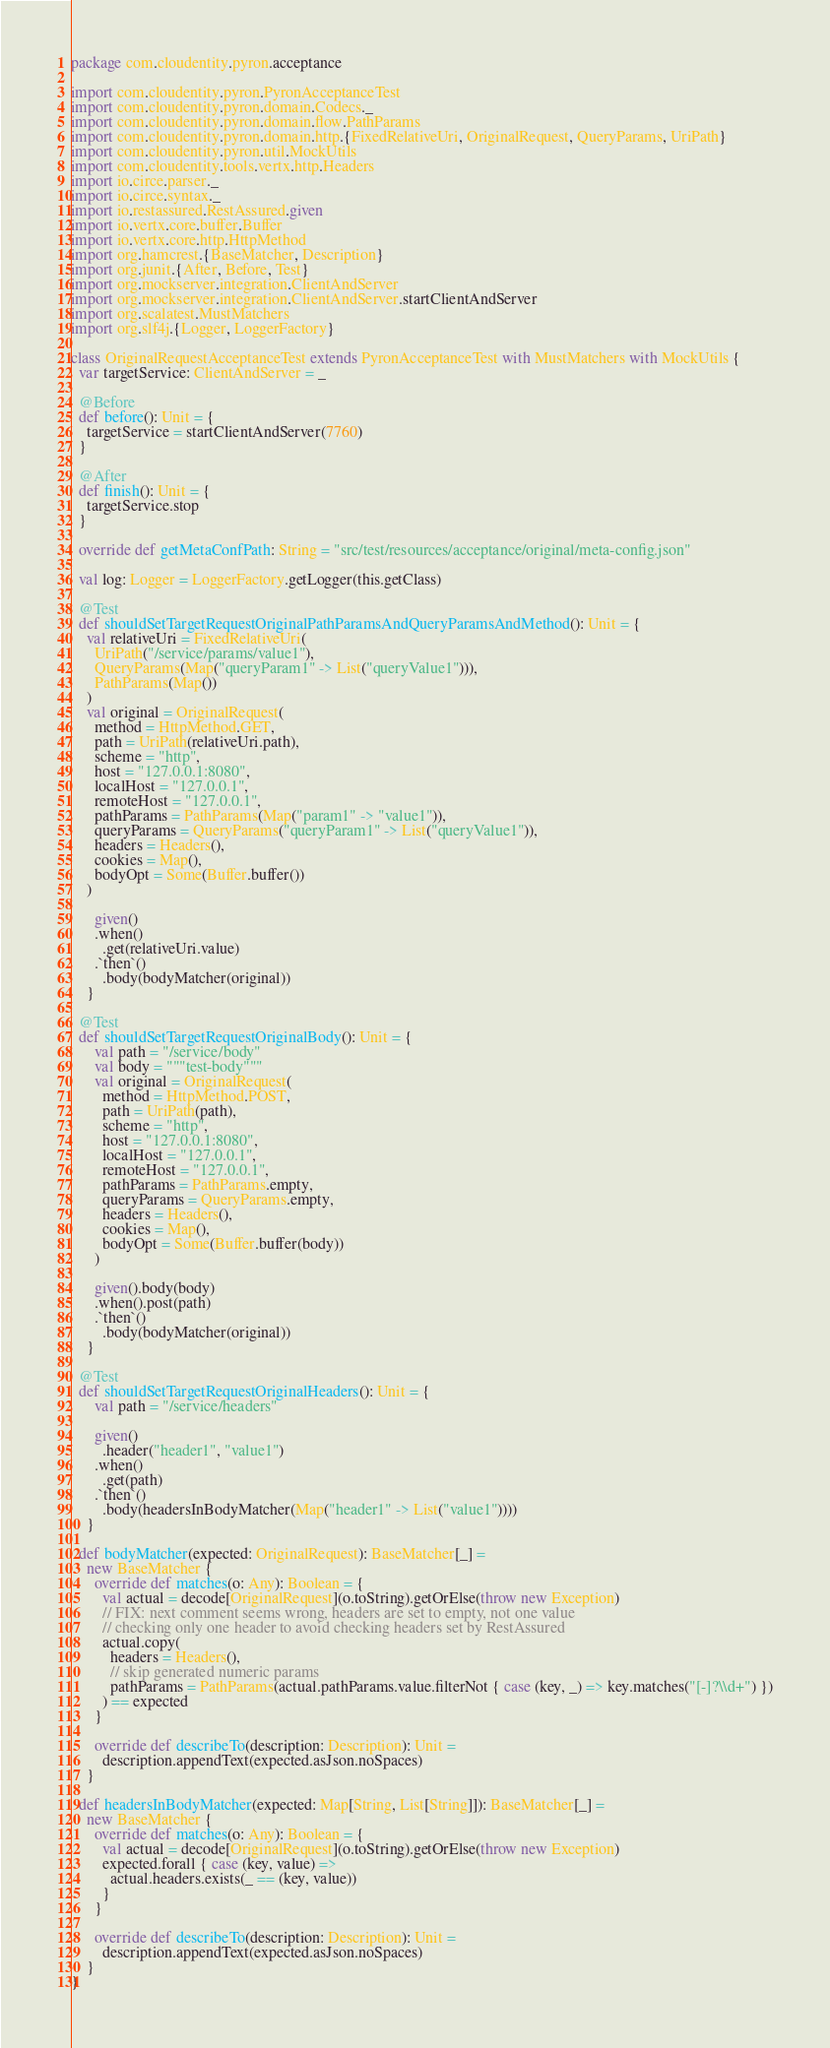<code> <loc_0><loc_0><loc_500><loc_500><_Scala_>package com.cloudentity.pyron.acceptance

import com.cloudentity.pyron.PyronAcceptanceTest
import com.cloudentity.pyron.domain.Codecs._
import com.cloudentity.pyron.domain.flow.PathParams
import com.cloudentity.pyron.domain.http.{FixedRelativeUri, OriginalRequest, QueryParams, UriPath}
import com.cloudentity.pyron.util.MockUtils
import com.cloudentity.tools.vertx.http.Headers
import io.circe.parser._
import io.circe.syntax._
import io.restassured.RestAssured.given
import io.vertx.core.buffer.Buffer
import io.vertx.core.http.HttpMethod
import org.hamcrest.{BaseMatcher, Description}
import org.junit.{After, Before, Test}
import org.mockserver.integration.ClientAndServer
import org.mockserver.integration.ClientAndServer.startClientAndServer
import org.scalatest.MustMatchers
import org.slf4j.{Logger, LoggerFactory}

class OriginalRequestAcceptanceTest extends PyronAcceptanceTest with MustMatchers with MockUtils {
  var targetService: ClientAndServer = _

  @Before
  def before(): Unit = {
    targetService = startClientAndServer(7760)
  }

  @After
  def finish(): Unit = {
    targetService.stop
  }

  override def getMetaConfPath: String = "src/test/resources/acceptance/original/meta-config.json"

  val log: Logger = LoggerFactory.getLogger(this.getClass)

  @Test
  def shouldSetTargetRequestOriginalPathParamsAndQueryParamsAndMethod(): Unit = {
    val relativeUri = FixedRelativeUri(
      UriPath("/service/params/value1"),
      QueryParams(Map("queryParam1" -> List("queryValue1"))),
      PathParams(Map())
    )
    val original = OriginalRequest(
      method = HttpMethod.GET,
      path = UriPath(relativeUri.path),
      scheme = "http",
      host = "127.0.0.1:8080",
      localHost = "127.0.0.1",
      remoteHost = "127.0.0.1",
      pathParams = PathParams(Map("param1" -> "value1")),
      queryParams = QueryParams("queryParam1" -> List("queryValue1")),
      headers = Headers(),
      cookies = Map(),
      bodyOpt = Some(Buffer.buffer())
    )

      given()
      .when()
        .get(relativeUri.value)
      .`then`()
        .body(bodyMatcher(original))
    }

  @Test
  def shouldSetTargetRequestOriginalBody(): Unit = {
      val path = "/service/body"
      val body = """test-body"""
      val original = OriginalRequest(
        method = HttpMethod.POST,
        path = UriPath(path),
        scheme = "http",
        host = "127.0.0.1:8080",
        localHost = "127.0.0.1",
        remoteHost = "127.0.0.1",
        pathParams = PathParams.empty,
        queryParams = QueryParams.empty,
        headers = Headers(),
        cookies = Map(),
        bodyOpt = Some(Buffer.buffer(body))
      )

      given().body(body)
      .when().post(path)
      .`then`()
        .body(bodyMatcher(original))
    }

  @Test
  def shouldSetTargetRequestOriginalHeaders(): Unit = {
      val path = "/service/headers"

      given()
        .header("header1", "value1")
      .when()
        .get(path)
      .`then`()
        .body(headersInBodyMatcher(Map("header1" -> List("value1"))))
    }

  def bodyMatcher(expected: OriginalRequest): BaseMatcher[_] =
    new BaseMatcher {
      override def matches(o: Any): Boolean = {
        val actual = decode[OriginalRequest](o.toString).getOrElse(throw new Exception)
        // FIX: next comment seems wrong, headers are set to empty, not one value
        // checking only one header to avoid checking headers set by RestAssured
        actual.copy(
          headers = Headers(),
          // skip generated numeric params
          pathParams = PathParams(actual.pathParams.value.filterNot { case (key, _) => key.matches("[-]?\\d+") })
        ) == expected
      }

      override def describeTo(description: Description): Unit =
        description.appendText(expected.asJson.noSpaces)
    }

  def headersInBodyMatcher(expected: Map[String, List[String]]): BaseMatcher[_] =
    new BaseMatcher {
      override def matches(o: Any): Boolean = {
        val actual = decode[OriginalRequest](o.toString).getOrElse(throw new Exception)
        expected.forall { case (key, value) =>
          actual.headers.exists(_ == (key, value))
        }
      }

      override def describeTo(description: Description): Unit =
        description.appendText(expected.asJson.noSpaces)
    }
}
</code> 